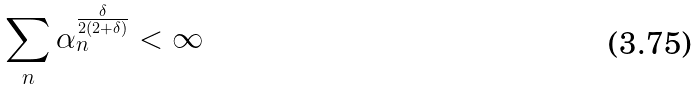<formula> <loc_0><loc_0><loc_500><loc_500>\sum _ { n } \alpha _ { n } ^ { \frac { \delta } { 2 ( 2 + \delta ) } } < \infty</formula> 